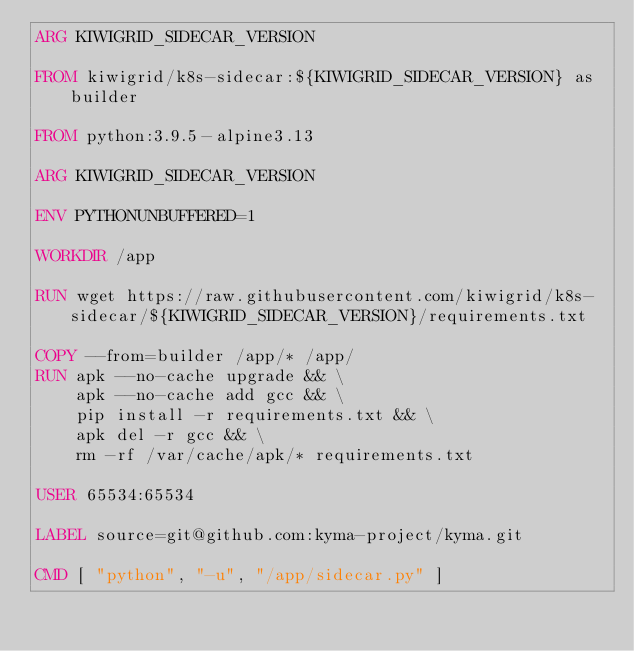Convert code to text. <code><loc_0><loc_0><loc_500><loc_500><_Dockerfile_>ARG KIWIGRID_SIDECAR_VERSION

FROM kiwigrid/k8s-sidecar:${KIWIGRID_SIDECAR_VERSION} as builder

FROM python:3.9.5-alpine3.13

ARG KIWIGRID_SIDECAR_VERSION

ENV PYTHONUNBUFFERED=1

WORKDIR /app

RUN wget https://raw.githubusercontent.com/kiwigrid/k8s-sidecar/${KIWIGRID_SIDECAR_VERSION}/requirements.txt

COPY --from=builder /app/* /app/
RUN apk --no-cache upgrade && \
    apk --no-cache add gcc && \
    pip install -r requirements.txt && \
    apk del -r gcc && \
    rm -rf /var/cache/apk/* requirements.txt

USER 65534:65534

LABEL source=git@github.com:kyma-project/kyma.git

CMD [ "python", "-u", "/app/sidecar.py" ]
</code> 